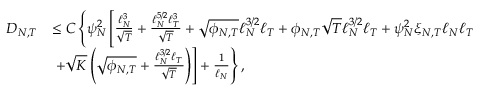<formula> <loc_0><loc_0><loc_500><loc_500>\begin{array} { r l } { { D _ { N , T } } } & { \leq C \left \{ \psi _ { N } ^ { 2 } \left [ \frac { \ell _ { N } ^ { 3 } } { \sqrt { T } } + \frac { \ell _ { N } ^ { 5 / 2 } \ell _ { T } ^ { 3 } } { \sqrt { T } } + \sqrt { \phi _ { N , T } } \ell _ { N } ^ { 3 / 2 } \ell _ { T } + \phi _ { N , T } \sqrt { T } \ell _ { N } ^ { 3 / 2 } \ell _ { T } + \psi _ { N } ^ { 2 } \xi _ { N , T } \ell _ { N } \ell _ { T } } \\ & { + \sqrt { K } \left ( \sqrt { \phi _ { N , T } } + \frac { \ell _ { N } ^ { 3 / 2 } \ell _ { T } } { \sqrt { T } } \right ) \right ] + \frac { 1 } { \ell _ { N } } \right \} , } \end{array}</formula> 